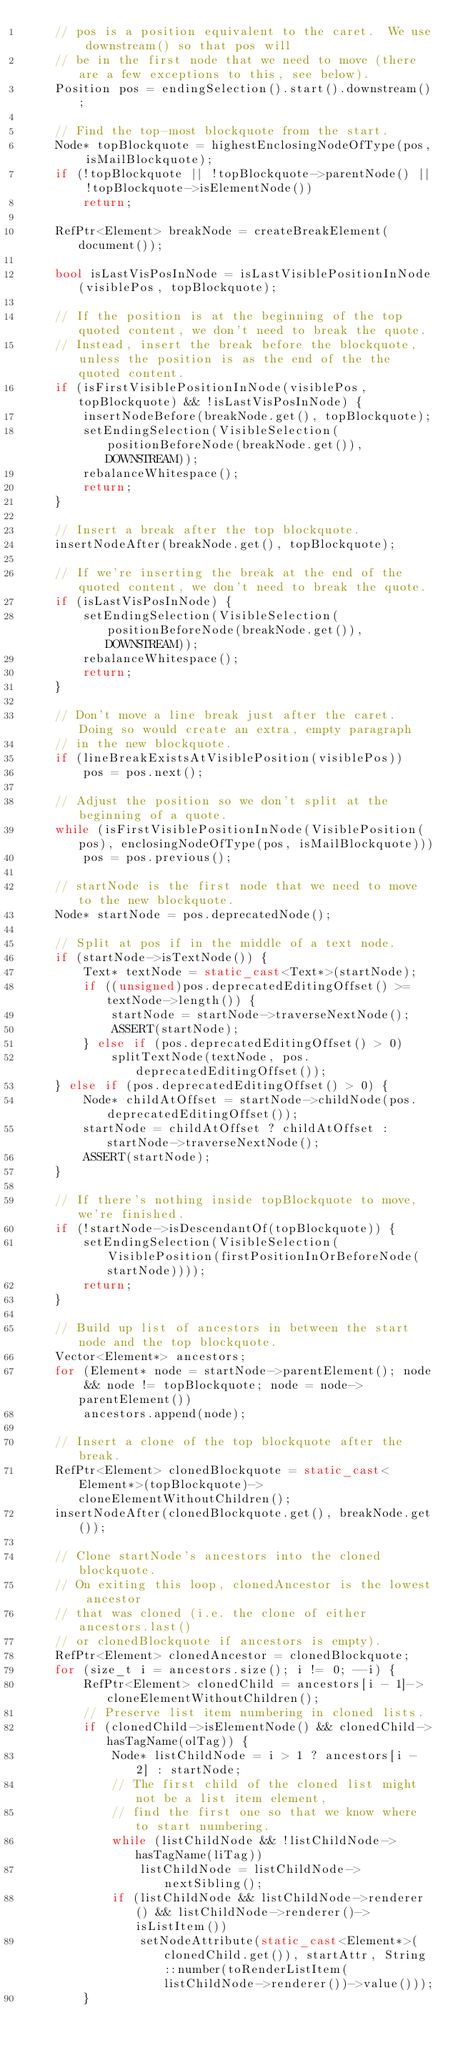<code> <loc_0><loc_0><loc_500><loc_500><_C++_>    // pos is a position equivalent to the caret.  We use downstream() so that pos will 
    // be in the first node that we need to move (there are a few exceptions to this, see below).
    Position pos = endingSelection().start().downstream();
    
    // Find the top-most blockquote from the start.
    Node* topBlockquote = highestEnclosingNodeOfType(pos, isMailBlockquote);
    if (!topBlockquote || !topBlockquote->parentNode() || !topBlockquote->isElementNode())
        return;
    
    RefPtr<Element> breakNode = createBreakElement(document());

    bool isLastVisPosInNode = isLastVisiblePositionInNode(visiblePos, topBlockquote);

    // If the position is at the beginning of the top quoted content, we don't need to break the quote.
    // Instead, insert the break before the blockquote, unless the position is as the end of the the quoted content.
    if (isFirstVisiblePositionInNode(visiblePos, topBlockquote) && !isLastVisPosInNode) {
        insertNodeBefore(breakNode.get(), topBlockquote);
        setEndingSelection(VisibleSelection(positionBeforeNode(breakNode.get()), DOWNSTREAM));
        rebalanceWhitespace();   
        return;
    }
    
    // Insert a break after the top blockquote.
    insertNodeAfter(breakNode.get(), topBlockquote);

    // If we're inserting the break at the end of the quoted content, we don't need to break the quote.
    if (isLastVisPosInNode) {
        setEndingSelection(VisibleSelection(positionBeforeNode(breakNode.get()), DOWNSTREAM));
        rebalanceWhitespace();
        return;
    }
    
    // Don't move a line break just after the caret.  Doing so would create an extra, empty paragraph
    // in the new blockquote.
    if (lineBreakExistsAtVisiblePosition(visiblePos))
        pos = pos.next();
        
    // Adjust the position so we don't split at the beginning of a quote.  
    while (isFirstVisiblePositionInNode(VisiblePosition(pos), enclosingNodeOfType(pos, isMailBlockquote)))
        pos = pos.previous();
    
    // startNode is the first node that we need to move to the new blockquote.
    Node* startNode = pos.deprecatedNode();
        
    // Split at pos if in the middle of a text node.
    if (startNode->isTextNode()) {
        Text* textNode = static_cast<Text*>(startNode);
        if ((unsigned)pos.deprecatedEditingOffset() >= textNode->length()) {
            startNode = startNode->traverseNextNode();
            ASSERT(startNode);
        } else if (pos.deprecatedEditingOffset() > 0)
            splitTextNode(textNode, pos.deprecatedEditingOffset());
    } else if (pos.deprecatedEditingOffset() > 0) {
        Node* childAtOffset = startNode->childNode(pos.deprecatedEditingOffset());
        startNode = childAtOffset ? childAtOffset : startNode->traverseNextNode();
        ASSERT(startNode);
    }
    
    // If there's nothing inside topBlockquote to move, we're finished.
    if (!startNode->isDescendantOf(topBlockquote)) {
        setEndingSelection(VisibleSelection(VisiblePosition(firstPositionInOrBeforeNode(startNode))));
        return;
    }
    
    // Build up list of ancestors in between the start node and the top blockquote.
    Vector<Element*> ancestors;    
    for (Element* node = startNode->parentElement(); node && node != topBlockquote; node = node->parentElement())
        ancestors.append(node);
    
    // Insert a clone of the top blockquote after the break.
    RefPtr<Element> clonedBlockquote = static_cast<Element*>(topBlockquote)->cloneElementWithoutChildren();
    insertNodeAfter(clonedBlockquote.get(), breakNode.get());
    
    // Clone startNode's ancestors into the cloned blockquote.
    // On exiting this loop, clonedAncestor is the lowest ancestor
    // that was cloned (i.e. the clone of either ancestors.last()
    // or clonedBlockquote if ancestors is empty).
    RefPtr<Element> clonedAncestor = clonedBlockquote;
    for (size_t i = ancestors.size(); i != 0; --i) {
        RefPtr<Element> clonedChild = ancestors[i - 1]->cloneElementWithoutChildren();
        // Preserve list item numbering in cloned lists.
        if (clonedChild->isElementNode() && clonedChild->hasTagName(olTag)) {
            Node* listChildNode = i > 1 ? ancestors[i - 2] : startNode;
            // The first child of the cloned list might not be a list item element, 
            // find the first one so that we know where to start numbering.
            while (listChildNode && !listChildNode->hasTagName(liTag))
                listChildNode = listChildNode->nextSibling();
            if (listChildNode && listChildNode->renderer() && listChildNode->renderer()->isListItem())
                setNodeAttribute(static_cast<Element*>(clonedChild.get()), startAttr, String::number(toRenderListItem(listChildNode->renderer())->value()));
        }
            </code> 